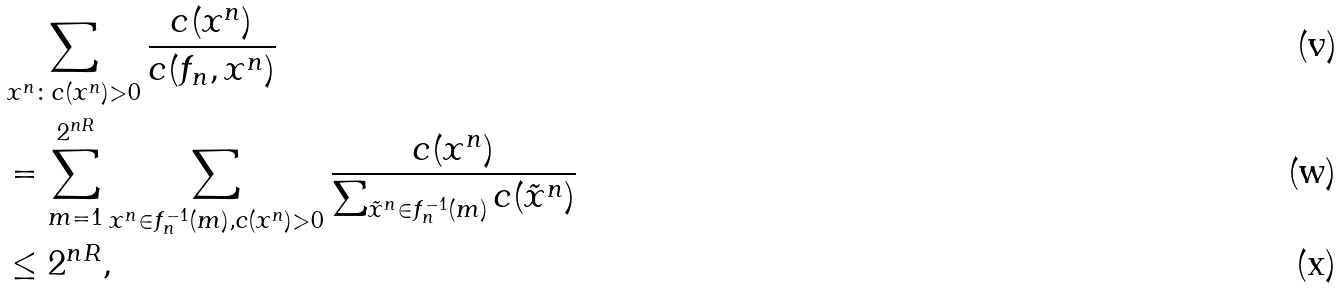<formula> <loc_0><loc_0><loc_500><loc_500>& \sum _ { x ^ { n } \colon c ( x ^ { n } ) > 0 } \frac { c ( x ^ { n } ) } { c ( f _ { n } , x ^ { n } ) } \\ & = \sum _ { m = 1 } ^ { 2 ^ { n R } } \sum _ { x ^ { n } \in f _ { n } ^ { - 1 } ( m ) , c ( x ^ { n } ) > 0 } \frac { c ( x ^ { n } ) } { \sum _ { \tilde { x } ^ { n } \in f _ { n } ^ { - 1 } ( m ) } c ( \tilde { x } ^ { n } ) } \\ & \leq 2 ^ { n R } ,</formula> 